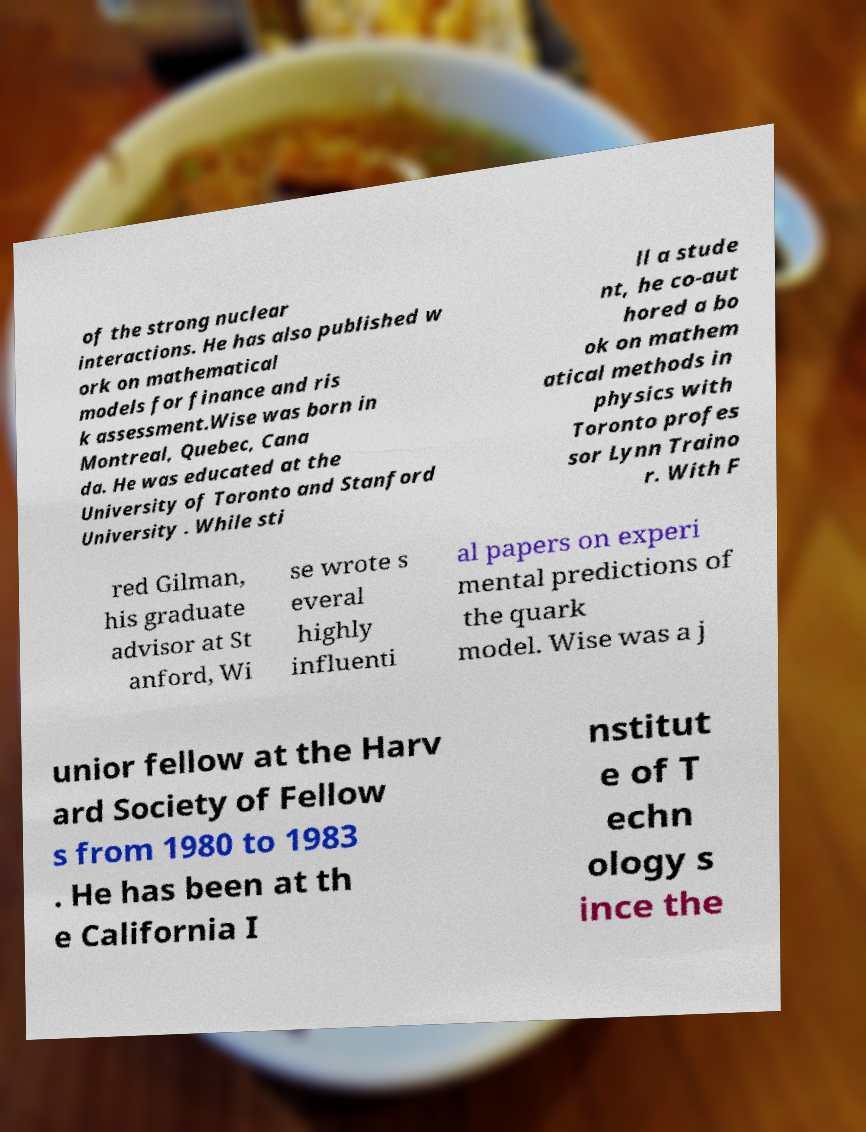For documentation purposes, I need the text within this image transcribed. Could you provide that? of the strong nuclear interactions. He has also published w ork on mathematical models for finance and ris k assessment.Wise was born in Montreal, Quebec, Cana da. He was educated at the University of Toronto and Stanford University . While sti ll a stude nt, he co-aut hored a bo ok on mathem atical methods in physics with Toronto profes sor Lynn Traino r. With F red Gilman, his graduate advisor at St anford, Wi se wrote s everal highly influenti al papers on experi mental predictions of the quark model. Wise was a j unior fellow at the Harv ard Society of Fellow s from 1980 to 1983 . He has been at th e California I nstitut e of T echn ology s ince the 